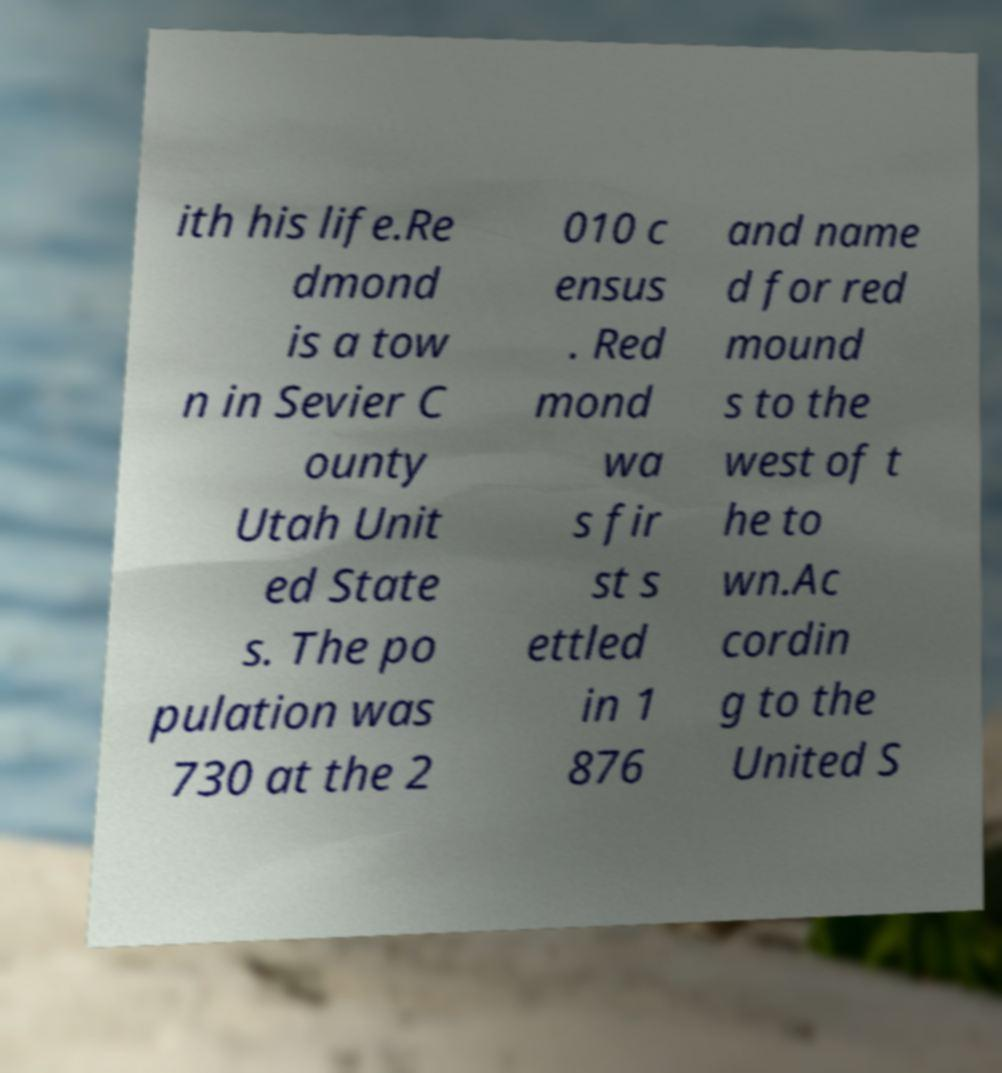Please identify and transcribe the text found in this image. ith his life.Re dmond is a tow n in Sevier C ounty Utah Unit ed State s. The po pulation was 730 at the 2 010 c ensus . Red mond wa s fir st s ettled in 1 876 and name d for red mound s to the west of t he to wn.Ac cordin g to the United S 